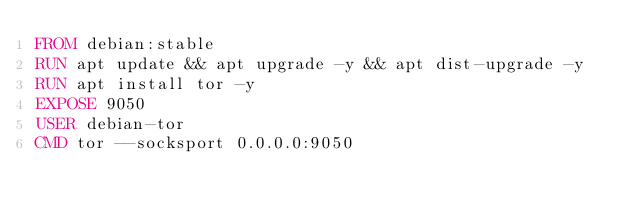Convert code to text. <code><loc_0><loc_0><loc_500><loc_500><_Dockerfile_>FROM debian:stable
RUN apt update && apt upgrade -y && apt dist-upgrade -y
RUN apt install tor -y
EXPOSE 9050
USER debian-tor
CMD tor --socksport 0.0.0.0:9050
</code> 